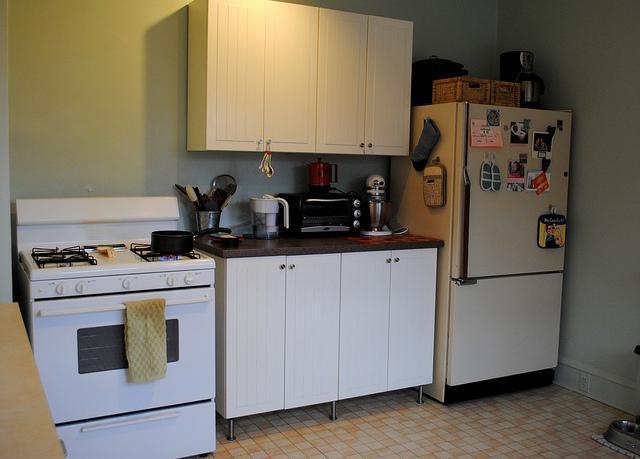How many burners does the stove have?
Give a very brief answer. 4. How many towels are there?
Give a very brief answer. 1. How many refrigerators are there?
Give a very brief answer. 1. How many gas stoves are in the room?
Give a very brief answer. 1. How many ovens can you see?
Give a very brief answer. 2. How many green spray bottles are there?
Give a very brief answer. 0. 